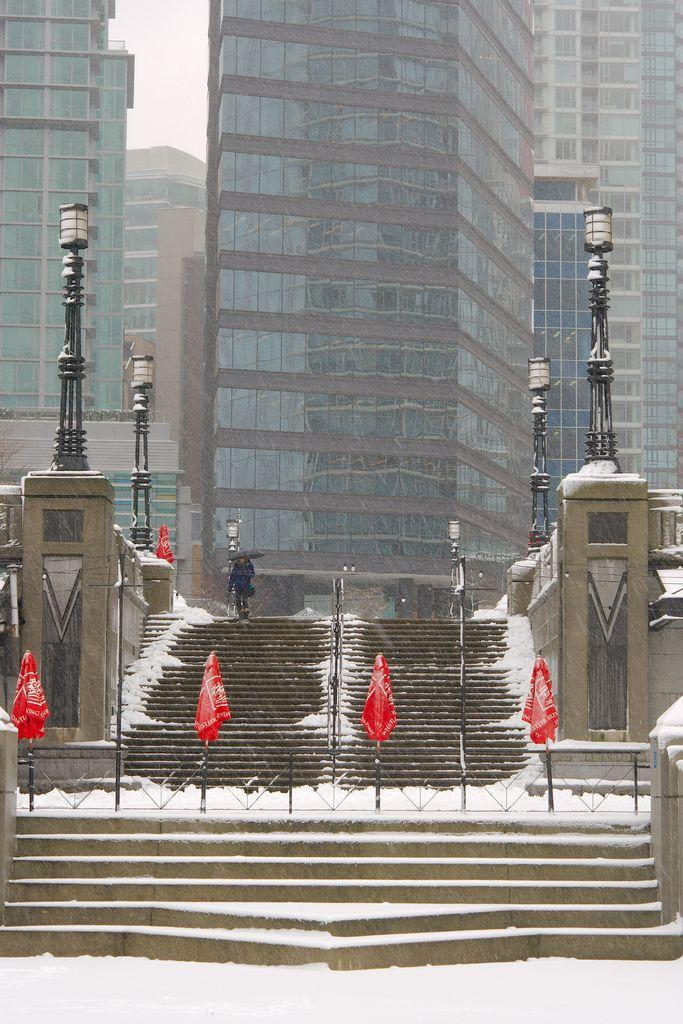What is a primary element visible in the image? The sky is a primary element visible in the image. What can be observed in the sky? Clouds are present in the image. What type of structures can be seen in the image? There are buildings, a wall, and a staircase visible in the image. What is used to hold flags in the image? Poles are present in the image to hold flags. What is the purpose of the fence in the image? The fence is present in the image to provide a boundary or separation. Can you describe the person in the image? There is a person standing in the image. What type of vest is the authority figure wearing in the image? A: There is no authority figure or vest present in the image. 